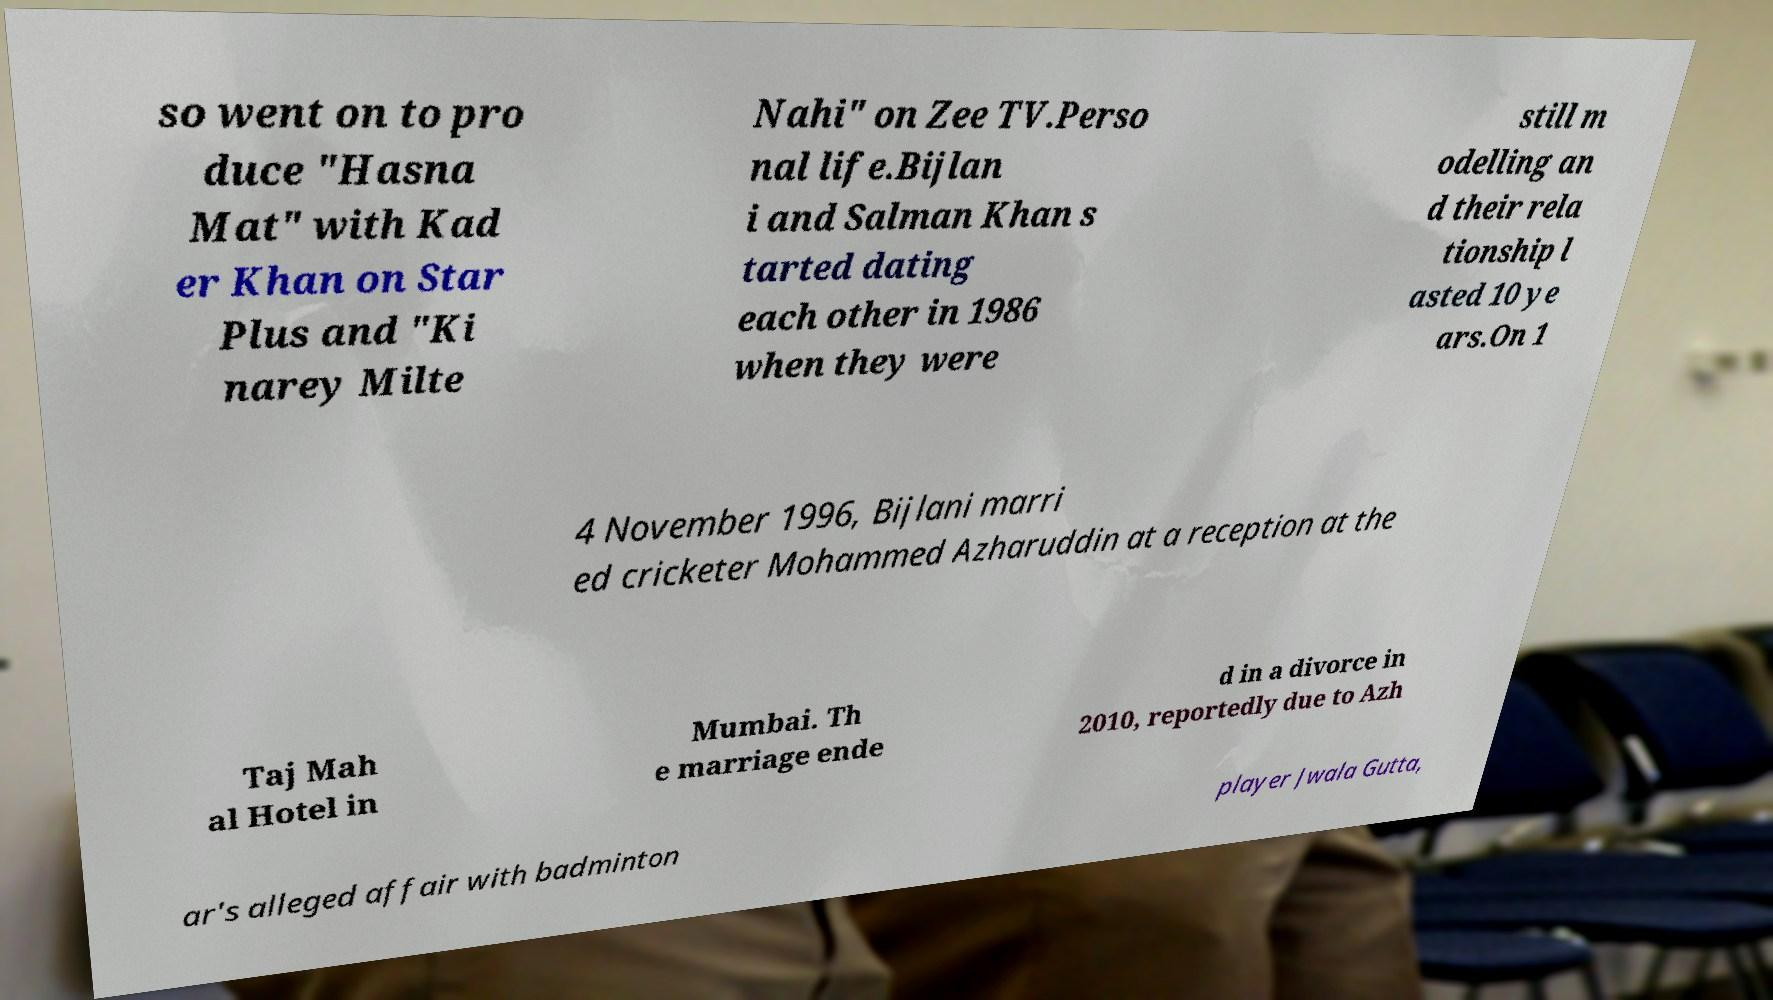There's text embedded in this image that I need extracted. Can you transcribe it verbatim? so went on to pro duce "Hasna Mat" with Kad er Khan on Star Plus and "Ki narey Milte Nahi" on Zee TV.Perso nal life.Bijlan i and Salman Khan s tarted dating each other in 1986 when they were still m odelling an d their rela tionship l asted 10 ye ars.On 1 4 November 1996, Bijlani marri ed cricketer Mohammed Azharuddin at a reception at the Taj Mah al Hotel in Mumbai. Th e marriage ende d in a divorce in 2010, reportedly due to Azh ar's alleged affair with badminton player Jwala Gutta, 